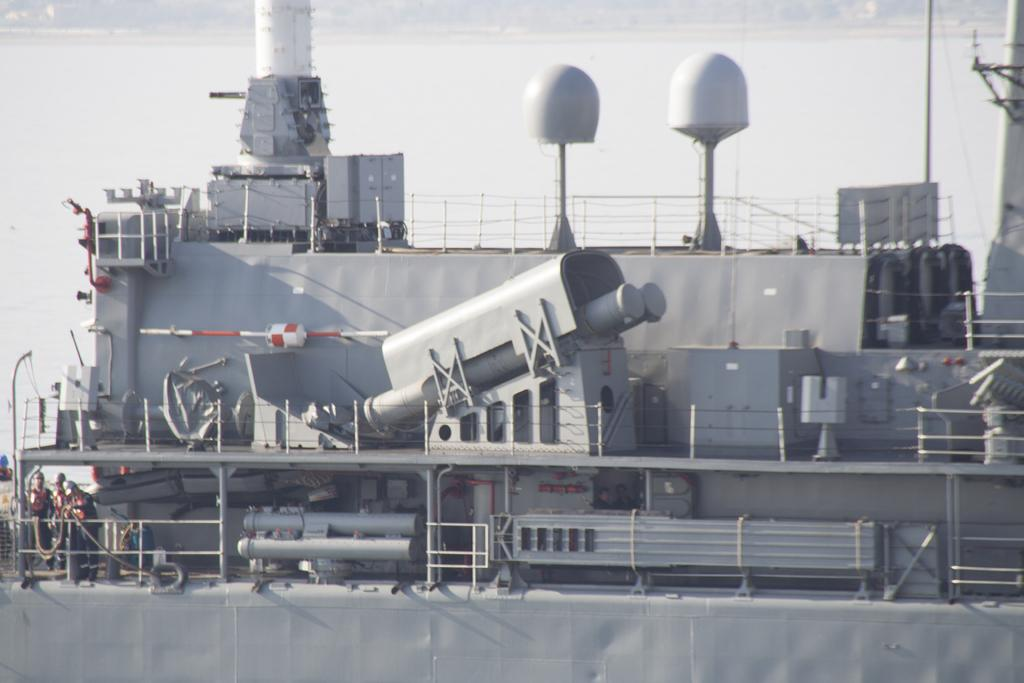What is the main subject of the image? The main subject of the image is a ship. What can be seen on the ship? There are people standing on the ship. What is visible in front of the people on the ship? There is water in front of the people on the ship. What is visible behind the ship? There is water behind the ship. How many straws are being used by the ladybug in the image? There is no ladybug or straw present in the image. What is the ship's mindset while sailing in the water? The ship does not have a mindset, as it is an inanimate object. 